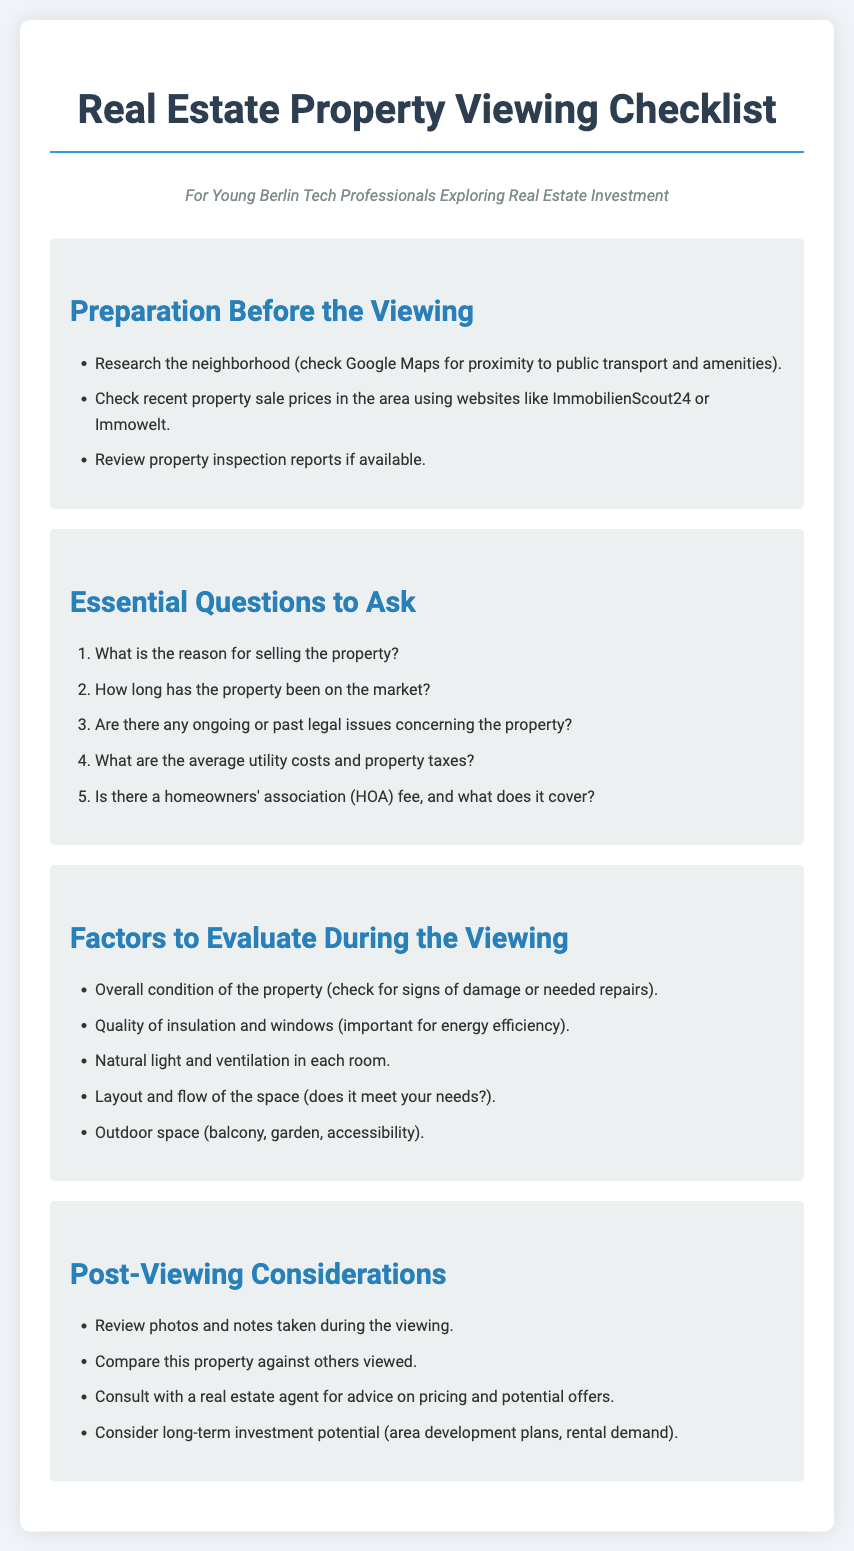what is the title of the document? The title of the document is prominently displayed at the top and is "Real Estate Property Viewing Checklist".
Answer: Real Estate Property Viewing Checklist who is the target audience for this checklist? The target audience is specified in the document and is "Young Berlin Tech Professionals Exploring Real Estate Investment".
Answer: Young Berlin Tech Professionals Exploring Real Estate Investment how many essential questions to ask are listed in the document? The number of essential questions is indicated by the total count in the list under the section "Essential Questions to Ask", which includes five questions.
Answer: 5 what factor addresses energy efficiency? The document specifies "Quality of insulation and windows" as a factor to evaluate during the viewing related to energy efficiency.
Answer: Quality of insulation and windows which website is mentioned for checking property sale prices? The document mentions ImmobilienScout24 and Immowelt as websites for checking recent property sale prices.
Answer: ImmobilienScout24 or Immowelt what should be reviewed post-viewing? The document advises to "Review photos and notes taken during the viewing" as a post-viewing consideration.
Answer: Review photos and notes taken during the viewing what is one reason to ask about selling the property? The document suggests asking, "What is the reason for selling the property?" to understand the seller's motivation.
Answer: Reason for selling the property how is the condition of the property evaluated? The overall condition of the property is evaluated by "checking for signs of damage or needed repairs" as stated in the document.
Answer: Checking for signs of damage or needed repairs 